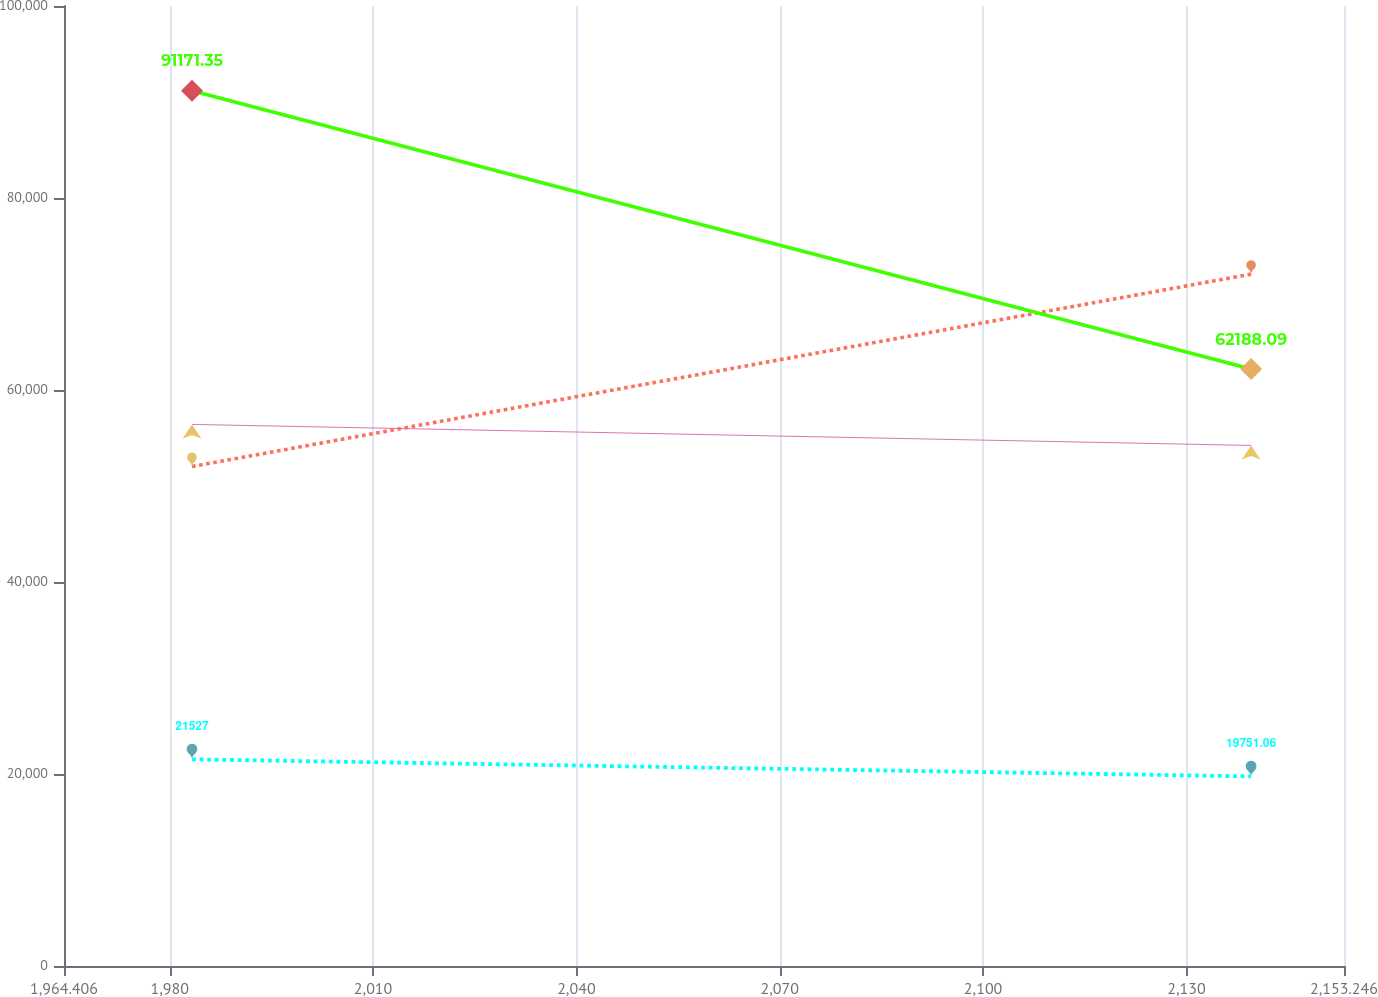Convert chart to OTSL. <chart><loc_0><loc_0><loc_500><loc_500><line_chart><ecel><fcel>Charged to costs and expenses<fcel>Deductions from reserves (b)<fcel>Charged to other accounts (a)<fcel>Balance at Jan. 1<nl><fcel>1983.29<fcel>56416<fcel>52028.9<fcel>21527<fcel>91171.4<nl><fcel>2139.54<fcel>54223.8<fcel>72069.6<fcel>19751.1<fcel>62188.1<nl><fcel>2172.13<fcel>33452.6<fcel>60259.6<fcel>18151.5<fcel>57722.6<nl></chart> 